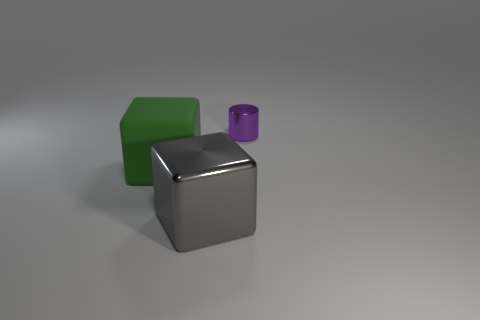Add 3 blue metal spheres. How many objects exist? 6 Subtract all cylinders. How many objects are left? 2 Subtract all green rubber cubes. Subtract all tiny cylinders. How many objects are left? 1 Add 3 large things. How many large things are left? 5 Add 2 tiny green cylinders. How many tiny green cylinders exist? 2 Subtract 0 brown cylinders. How many objects are left? 3 